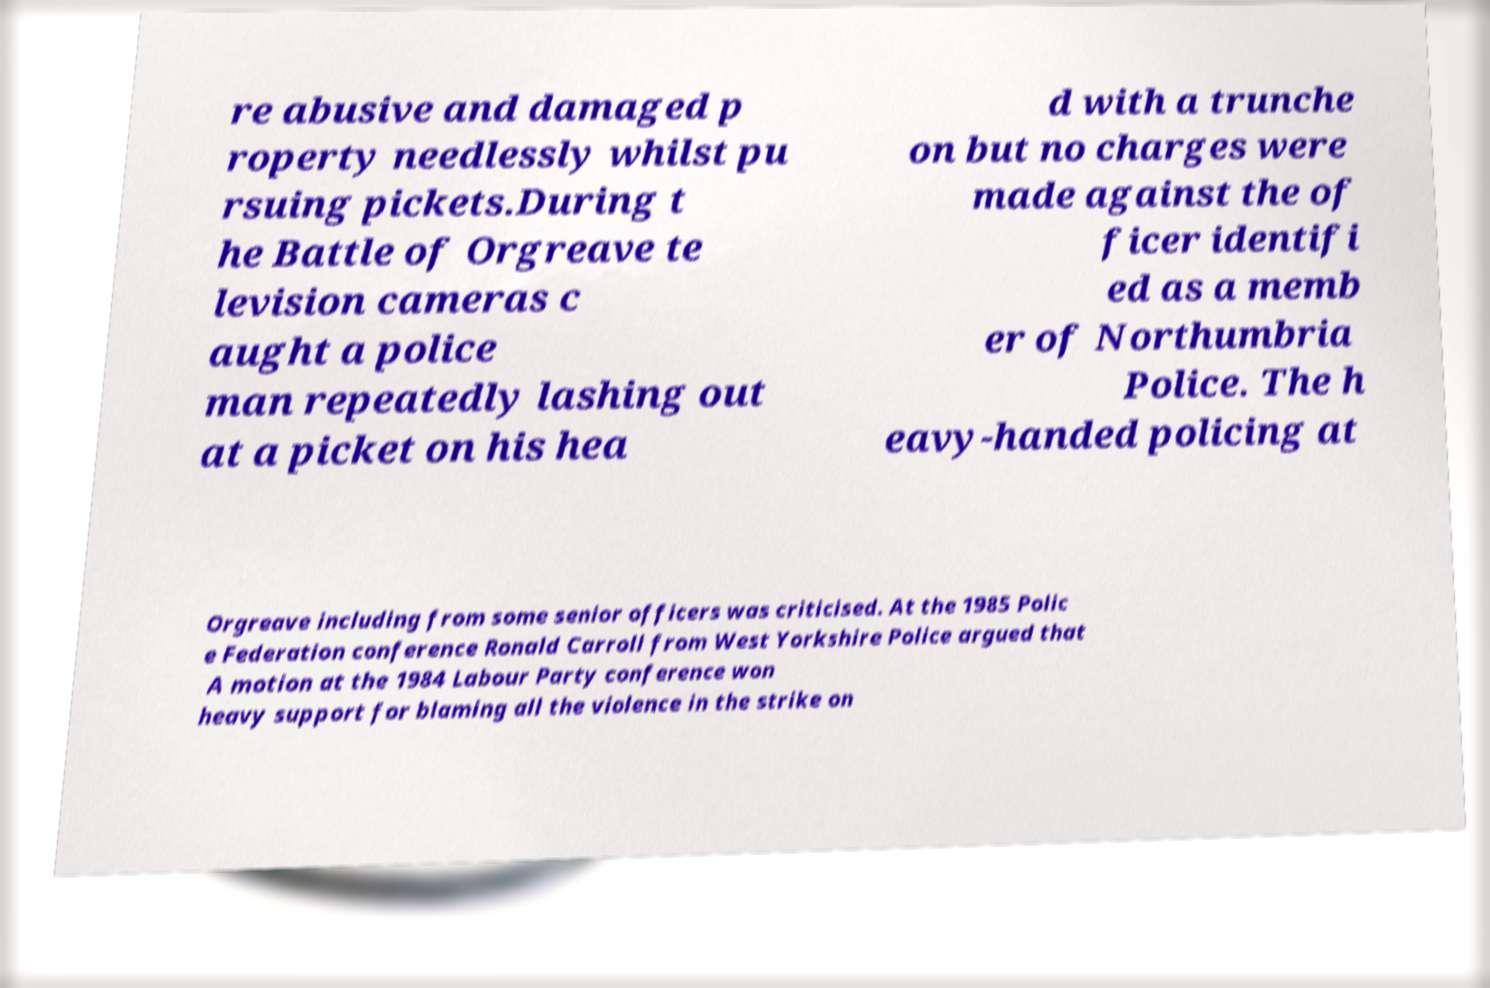Can you accurately transcribe the text from the provided image for me? re abusive and damaged p roperty needlessly whilst pu rsuing pickets.During t he Battle of Orgreave te levision cameras c aught a police man repeatedly lashing out at a picket on his hea d with a trunche on but no charges were made against the of ficer identifi ed as a memb er of Northumbria Police. The h eavy-handed policing at Orgreave including from some senior officers was criticised. At the 1985 Polic e Federation conference Ronald Carroll from West Yorkshire Police argued that A motion at the 1984 Labour Party conference won heavy support for blaming all the violence in the strike on 